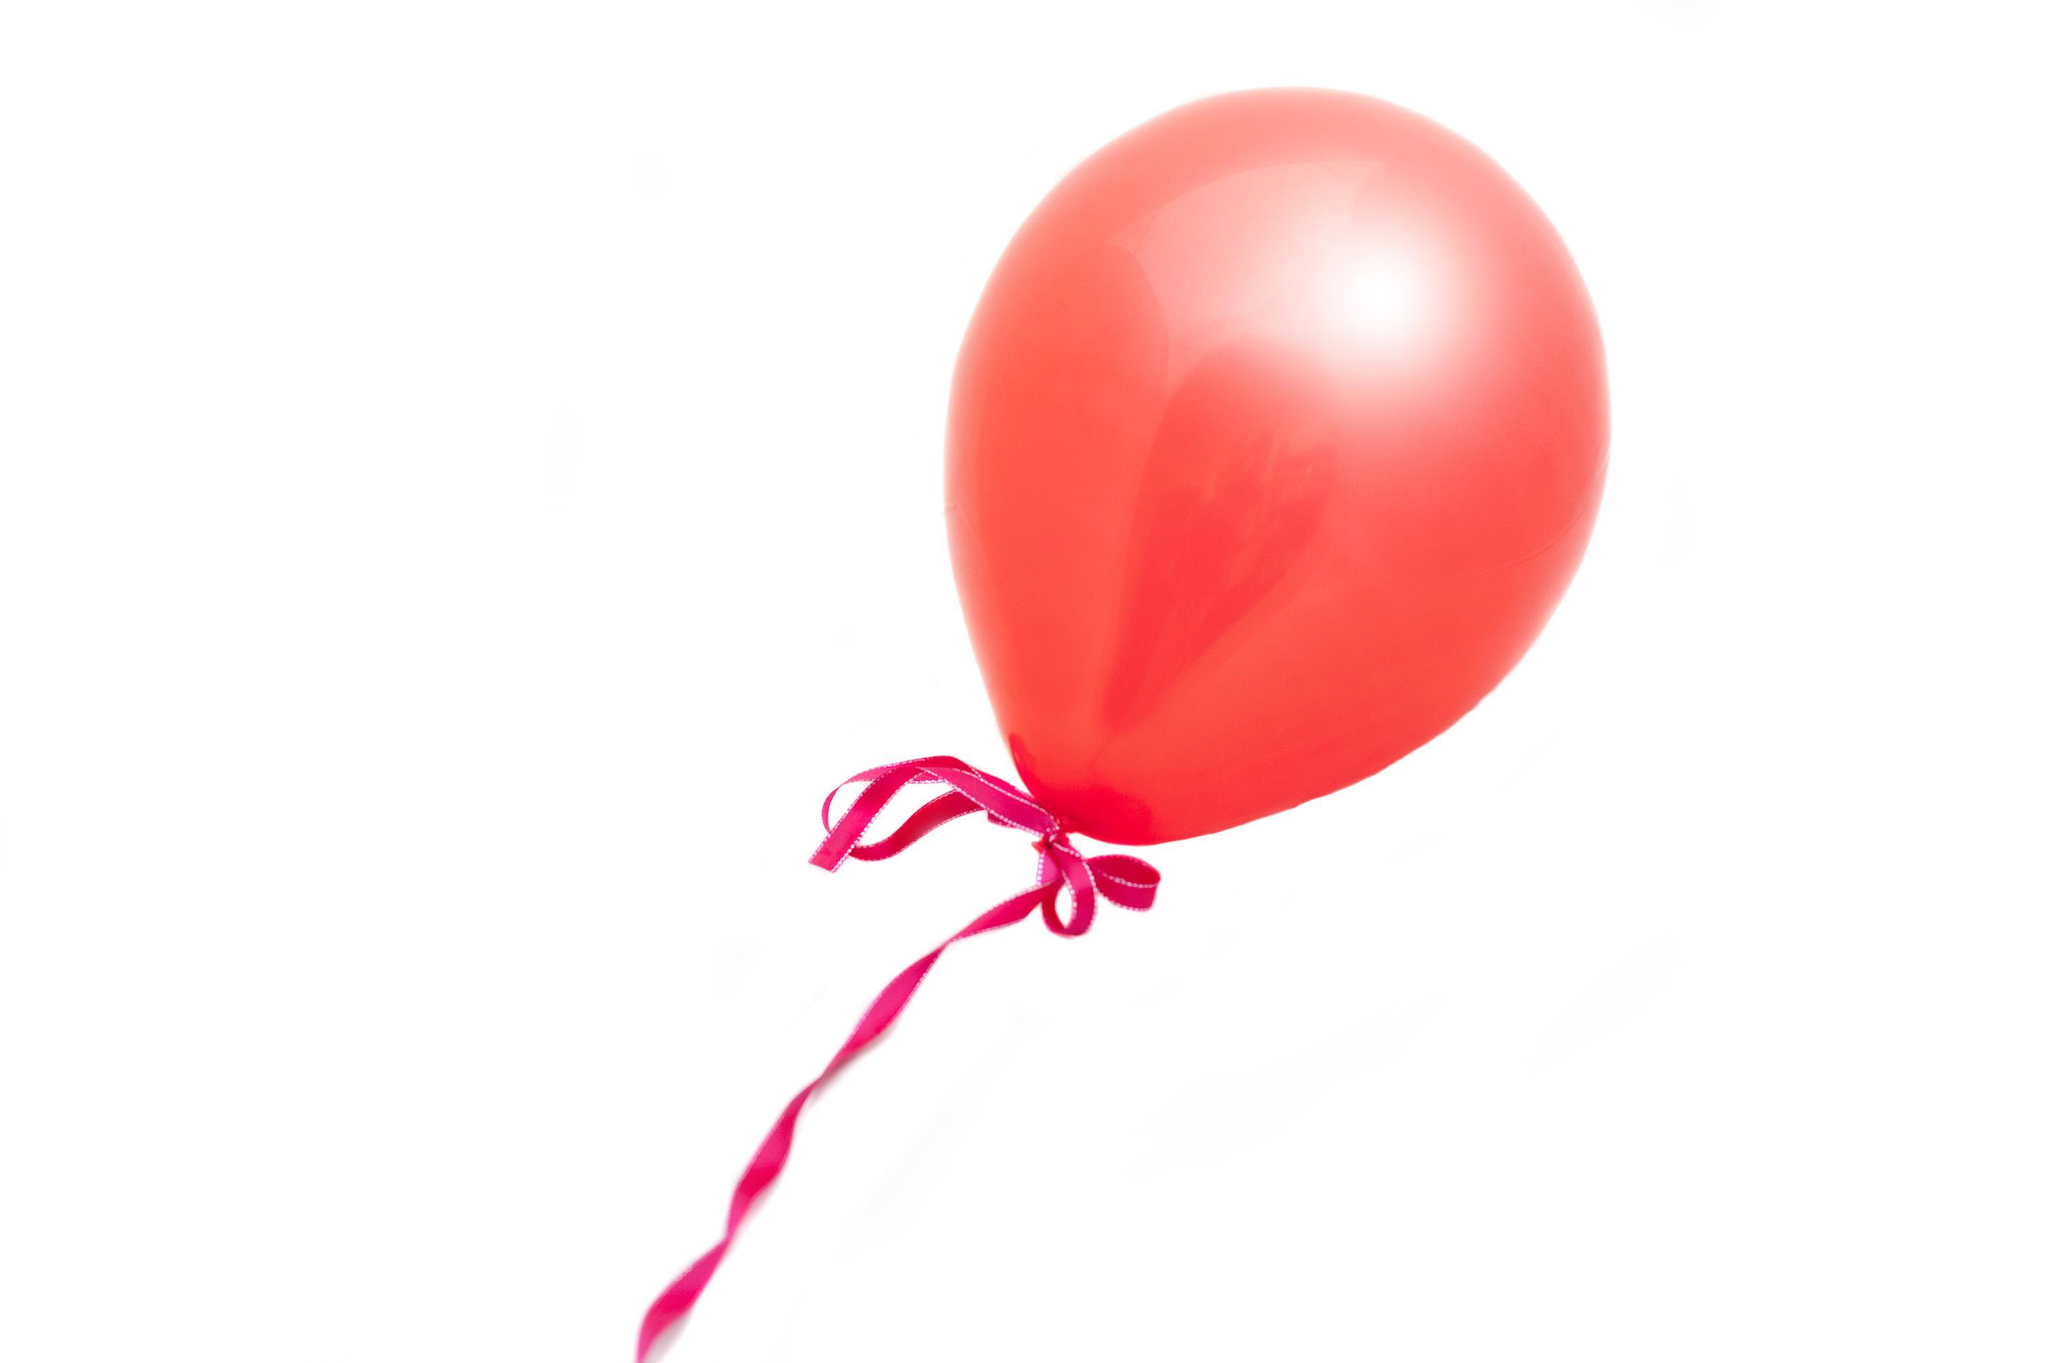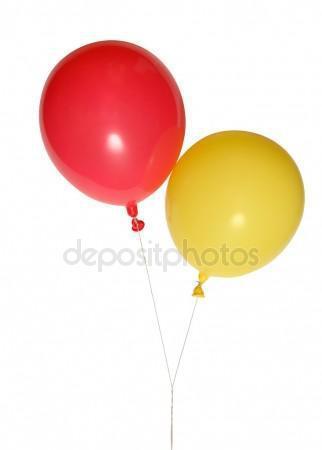The first image is the image on the left, the second image is the image on the right. For the images displayed, is the sentence "Each image shows exactly one aqua balloon next to one red balloon." factually correct? Answer yes or no. No. The first image is the image on the left, the second image is the image on the right. Considering the images on both sides, is "Each image shows one round red balloon and one round green balloon side by side" valid? Answer yes or no. No. 